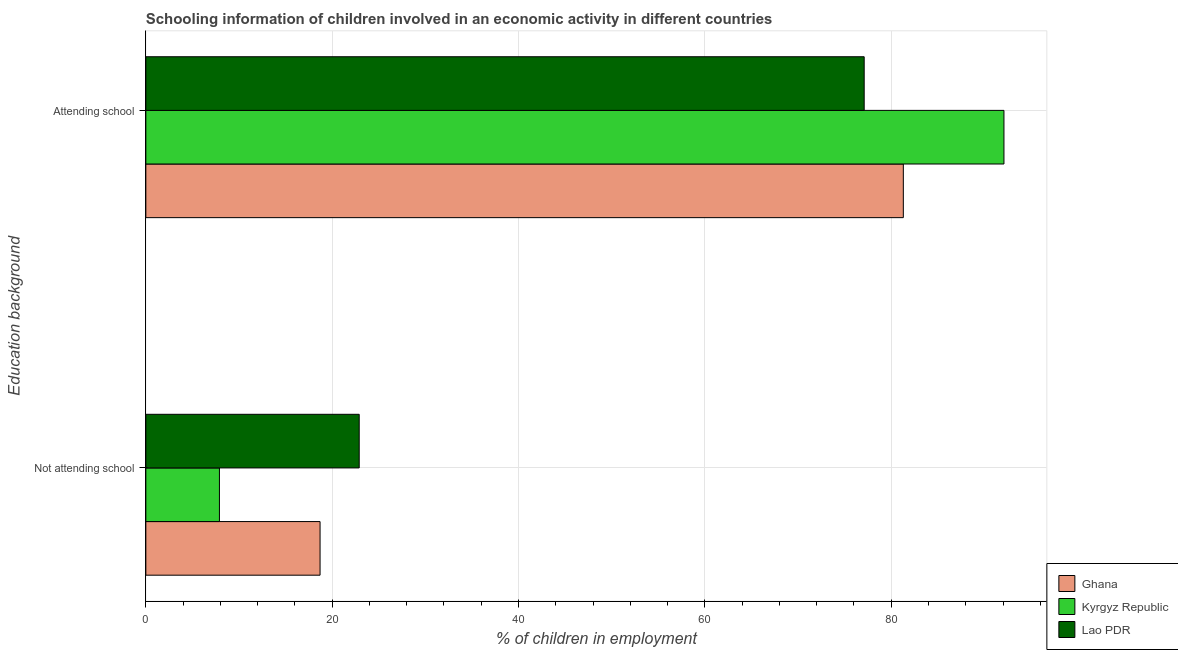How many groups of bars are there?
Provide a short and direct response. 2. Are the number of bars on each tick of the Y-axis equal?
Make the answer very short. Yes. How many bars are there on the 2nd tick from the bottom?
Provide a short and direct response. 3. What is the label of the 2nd group of bars from the top?
Give a very brief answer. Not attending school. What is the percentage of employed children who are attending school in Ghana?
Offer a very short reply. 81.3. Across all countries, what is the maximum percentage of employed children who are attending school?
Provide a short and direct response. 92.1. Across all countries, what is the minimum percentage of employed children who are attending school?
Your response must be concise. 77.1. In which country was the percentage of employed children who are attending school maximum?
Keep it short and to the point. Kyrgyz Republic. In which country was the percentage of employed children who are not attending school minimum?
Offer a terse response. Kyrgyz Republic. What is the total percentage of employed children who are attending school in the graph?
Provide a succinct answer. 250.5. What is the difference between the percentage of employed children who are not attending school in Lao PDR and that in Ghana?
Your response must be concise. 4.2. What is the difference between the percentage of employed children who are attending school in Kyrgyz Republic and the percentage of employed children who are not attending school in Lao PDR?
Provide a succinct answer. 69.2. What is the average percentage of employed children who are attending school per country?
Keep it short and to the point. 83.5. What is the difference between the percentage of employed children who are attending school and percentage of employed children who are not attending school in Kyrgyz Republic?
Offer a very short reply. 84.2. What is the ratio of the percentage of employed children who are attending school in Lao PDR to that in Kyrgyz Republic?
Your answer should be compact. 0.84. Is the percentage of employed children who are attending school in Ghana less than that in Lao PDR?
Offer a terse response. No. How many countries are there in the graph?
Provide a short and direct response. 3. What is the difference between two consecutive major ticks on the X-axis?
Your response must be concise. 20. Does the graph contain grids?
Provide a short and direct response. Yes. Where does the legend appear in the graph?
Your response must be concise. Bottom right. How are the legend labels stacked?
Offer a terse response. Vertical. What is the title of the graph?
Offer a terse response. Schooling information of children involved in an economic activity in different countries. What is the label or title of the X-axis?
Keep it short and to the point. % of children in employment. What is the label or title of the Y-axis?
Your response must be concise. Education background. What is the % of children in employment in Kyrgyz Republic in Not attending school?
Ensure brevity in your answer.  7.9. What is the % of children in employment in Lao PDR in Not attending school?
Provide a succinct answer. 22.9. What is the % of children in employment of Ghana in Attending school?
Give a very brief answer. 81.3. What is the % of children in employment of Kyrgyz Republic in Attending school?
Make the answer very short. 92.1. What is the % of children in employment in Lao PDR in Attending school?
Offer a very short reply. 77.1. Across all Education background, what is the maximum % of children in employment of Ghana?
Offer a terse response. 81.3. Across all Education background, what is the maximum % of children in employment of Kyrgyz Republic?
Keep it short and to the point. 92.1. Across all Education background, what is the maximum % of children in employment in Lao PDR?
Offer a terse response. 77.1. Across all Education background, what is the minimum % of children in employment of Kyrgyz Republic?
Provide a succinct answer. 7.9. Across all Education background, what is the minimum % of children in employment of Lao PDR?
Make the answer very short. 22.9. What is the total % of children in employment in Ghana in the graph?
Offer a very short reply. 100. What is the total % of children in employment in Lao PDR in the graph?
Your answer should be very brief. 100. What is the difference between the % of children in employment in Ghana in Not attending school and that in Attending school?
Your answer should be compact. -62.6. What is the difference between the % of children in employment of Kyrgyz Republic in Not attending school and that in Attending school?
Ensure brevity in your answer.  -84.2. What is the difference between the % of children in employment in Lao PDR in Not attending school and that in Attending school?
Offer a very short reply. -54.2. What is the difference between the % of children in employment of Ghana in Not attending school and the % of children in employment of Kyrgyz Republic in Attending school?
Your answer should be very brief. -73.4. What is the difference between the % of children in employment of Ghana in Not attending school and the % of children in employment of Lao PDR in Attending school?
Your response must be concise. -58.4. What is the difference between the % of children in employment in Kyrgyz Republic in Not attending school and the % of children in employment in Lao PDR in Attending school?
Provide a succinct answer. -69.2. What is the average % of children in employment in Ghana per Education background?
Make the answer very short. 50. What is the average % of children in employment in Lao PDR per Education background?
Your answer should be compact. 50. What is the difference between the % of children in employment of Ghana and % of children in employment of Kyrgyz Republic in Not attending school?
Offer a very short reply. 10.8. What is the difference between the % of children in employment of Kyrgyz Republic and % of children in employment of Lao PDR in Not attending school?
Give a very brief answer. -15. What is the difference between the % of children in employment of Ghana and % of children in employment of Lao PDR in Attending school?
Your answer should be compact. 4.2. What is the difference between the % of children in employment in Kyrgyz Republic and % of children in employment in Lao PDR in Attending school?
Offer a very short reply. 15. What is the ratio of the % of children in employment in Ghana in Not attending school to that in Attending school?
Offer a very short reply. 0.23. What is the ratio of the % of children in employment in Kyrgyz Republic in Not attending school to that in Attending school?
Your answer should be compact. 0.09. What is the ratio of the % of children in employment of Lao PDR in Not attending school to that in Attending school?
Give a very brief answer. 0.3. What is the difference between the highest and the second highest % of children in employment of Ghana?
Provide a short and direct response. 62.6. What is the difference between the highest and the second highest % of children in employment of Kyrgyz Republic?
Give a very brief answer. 84.2. What is the difference between the highest and the second highest % of children in employment of Lao PDR?
Ensure brevity in your answer.  54.2. What is the difference between the highest and the lowest % of children in employment of Ghana?
Offer a terse response. 62.6. What is the difference between the highest and the lowest % of children in employment of Kyrgyz Republic?
Offer a terse response. 84.2. What is the difference between the highest and the lowest % of children in employment of Lao PDR?
Ensure brevity in your answer.  54.2. 